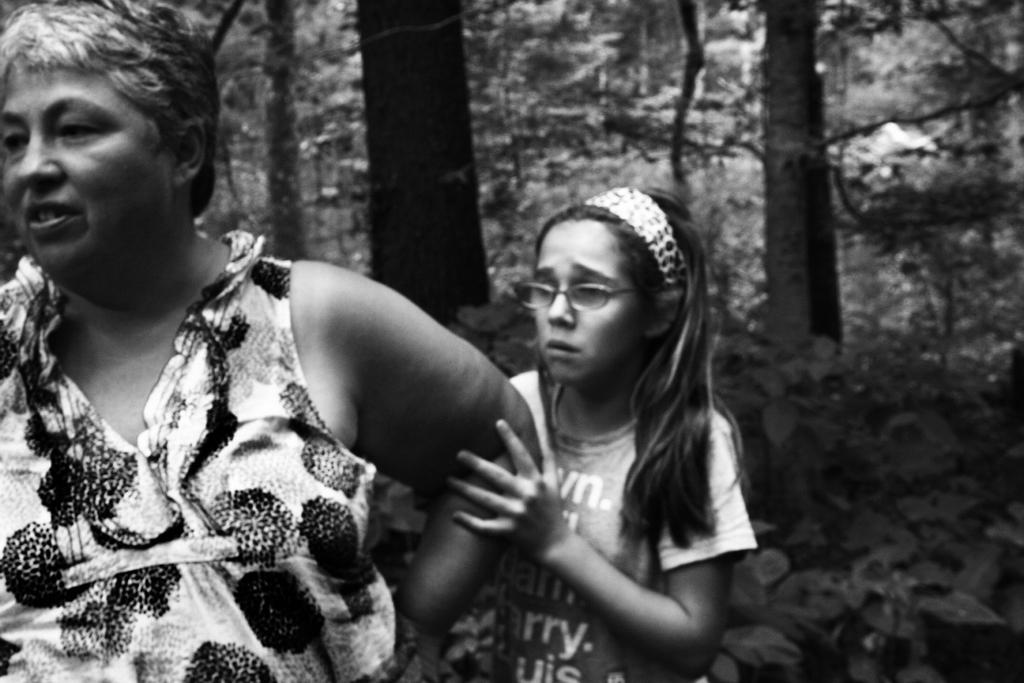How many people are in the image? There are two persons standing in the center of the image. Can you describe the girl in the image? The girl is wearing glasses. What can be seen in the background of the image? There are trees visible in the background of the image. How many houses can be seen in the image? There are no houses visible in the image; it only features two persons and trees in the background. Are there any ducks present in the image? There are no ducks present in the image. 